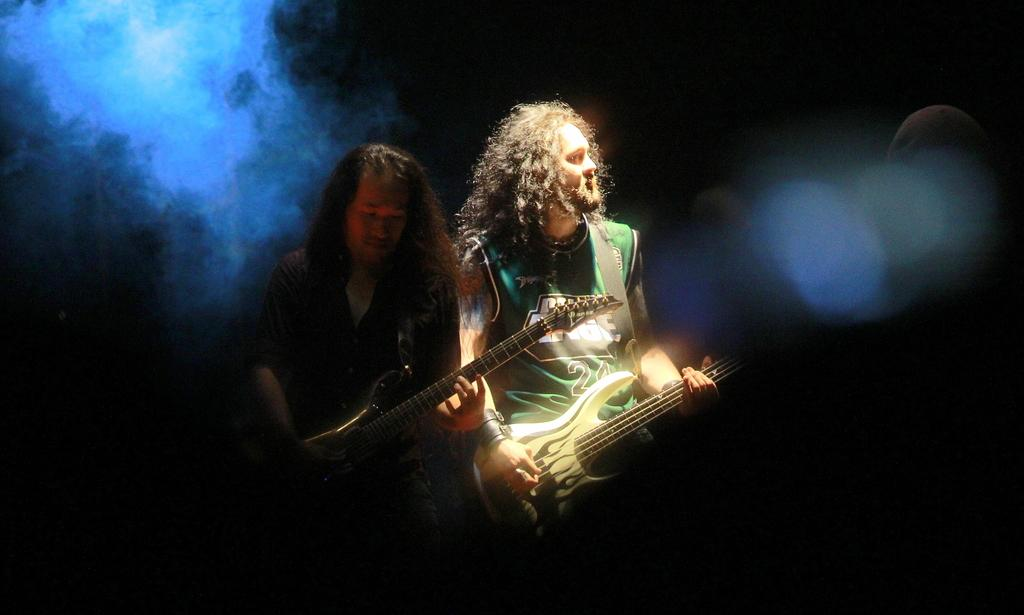What is the color of the background in the image? The background of the image is dark. What can be seen in the image besides the two men? There is smoke visible in the image. What is the appearance of the men's hair? The men have curly long hair. What are the men doing in the image? The men are standing and playing guitars. How many pizzas are being served on the stone net in the image? There are no pizzas, stone, or net present in the image. 